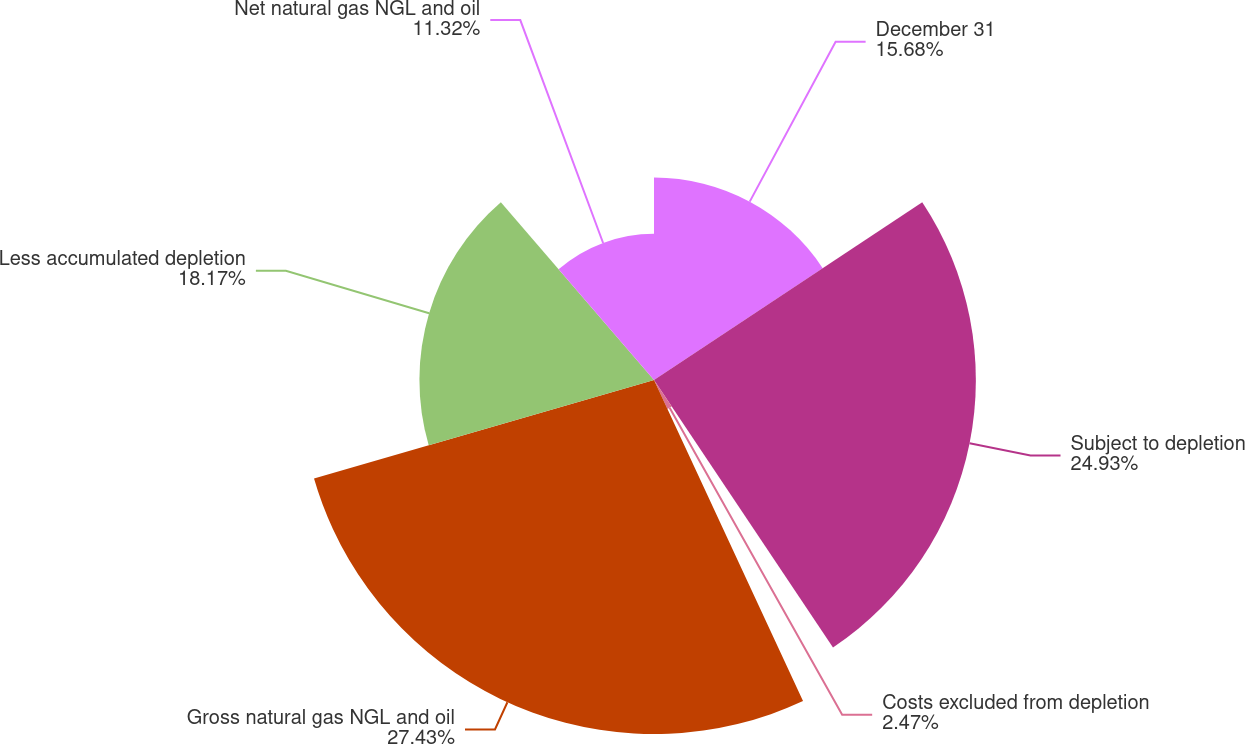Convert chart to OTSL. <chart><loc_0><loc_0><loc_500><loc_500><pie_chart><fcel>December 31<fcel>Subject to depletion<fcel>Costs excluded from depletion<fcel>Gross natural gas NGL and oil<fcel>Less accumulated depletion<fcel>Net natural gas NGL and oil<nl><fcel>15.68%<fcel>24.93%<fcel>2.47%<fcel>27.42%<fcel>18.17%<fcel>11.32%<nl></chart> 